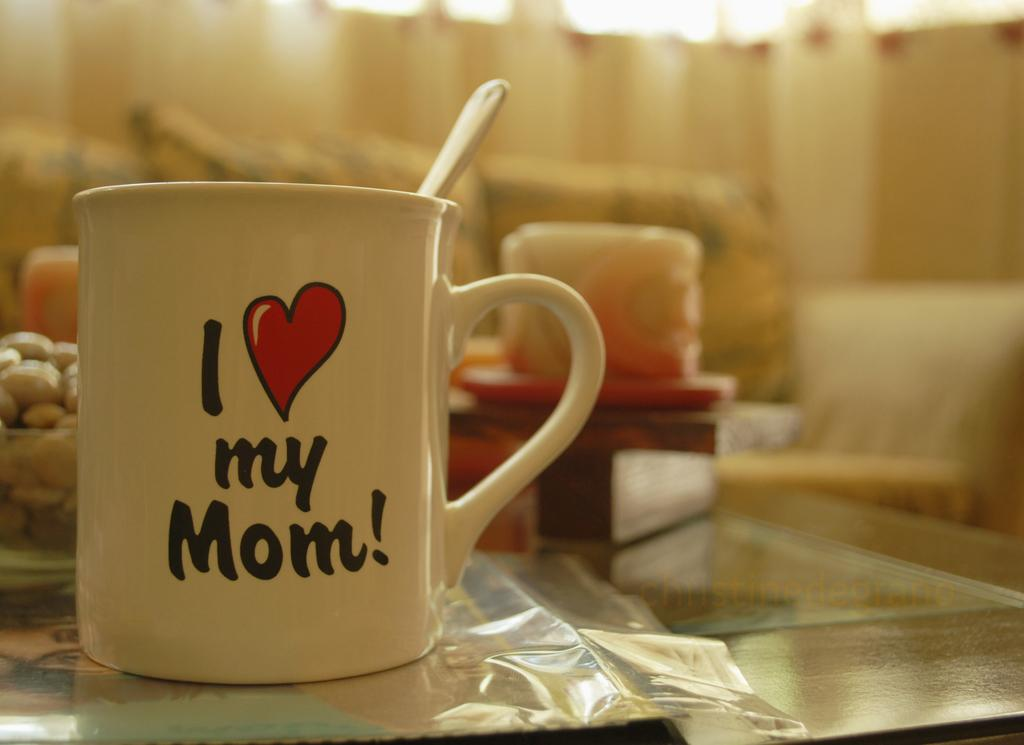<image>
Describe the image concisely. A white mug cheerily proclaims: "I heart my mum!". 